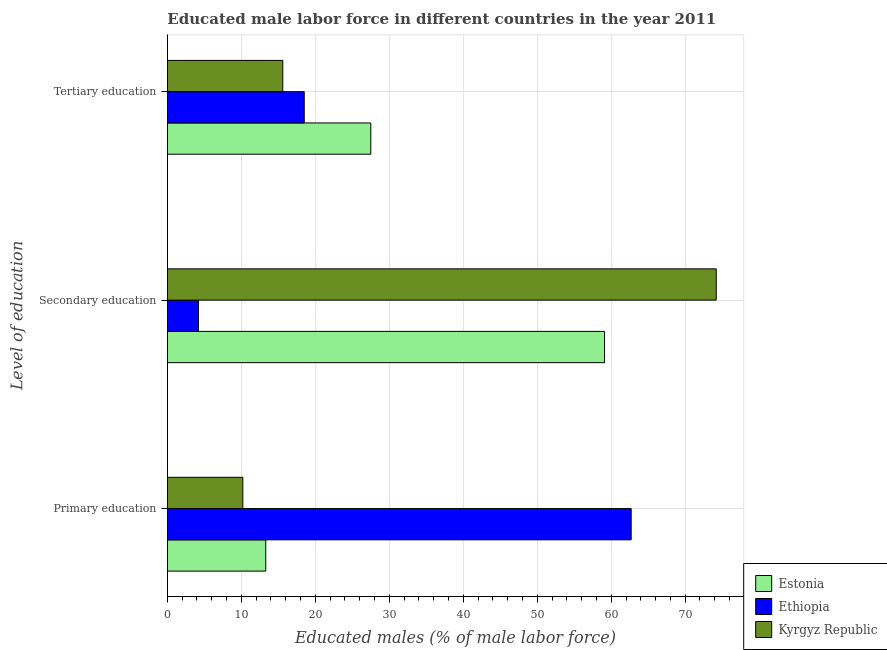Are the number of bars per tick equal to the number of legend labels?
Offer a terse response. Yes. Are the number of bars on each tick of the Y-axis equal?
Keep it short and to the point. Yes. What is the label of the 2nd group of bars from the top?
Ensure brevity in your answer.  Secondary education. What is the percentage of male labor force who received tertiary education in Estonia?
Your answer should be compact. 27.5. Across all countries, what is the maximum percentage of male labor force who received primary education?
Your answer should be compact. 62.7. Across all countries, what is the minimum percentage of male labor force who received secondary education?
Your answer should be compact. 4.2. In which country was the percentage of male labor force who received tertiary education maximum?
Provide a succinct answer. Estonia. In which country was the percentage of male labor force who received primary education minimum?
Keep it short and to the point. Kyrgyz Republic. What is the total percentage of male labor force who received primary education in the graph?
Offer a very short reply. 86.2. What is the difference between the percentage of male labor force who received primary education in Kyrgyz Republic and that in Estonia?
Provide a succinct answer. -3.1. What is the difference between the percentage of male labor force who received secondary education in Kyrgyz Republic and the percentage of male labor force who received tertiary education in Estonia?
Keep it short and to the point. 46.7. What is the average percentage of male labor force who received secondary education per country?
Your answer should be very brief. 45.83. What is the difference between the percentage of male labor force who received secondary education and percentage of male labor force who received primary education in Ethiopia?
Provide a succinct answer. -58.5. What is the ratio of the percentage of male labor force who received tertiary education in Ethiopia to that in Kyrgyz Republic?
Ensure brevity in your answer.  1.19. Is the difference between the percentage of male labor force who received tertiary education in Estonia and Kyrgyz Republic greater than the difference between the percentage of male labor force who received primary education in Estonia and Kyrgyz Republic?
Your response must be concise. Yes. What is the difference between the highest and the second highest percentage of male labor force who received tertiary education?
Give a very brief answer. 9. What is the difference between the highest and the lowest percentage of male labor force who received secondary education?
Provide a short and direct response. 70. In how many countries, is the percentage of male labor force who received tertiary education greater than the average percentage of male labor force who received tertiary education taken over all countries?
Provide a short and direct response. 1. What does the 2nd bar from the top in Primary education represents?
Offer a very short reply. Ethiopia. What does the 1st bar from the bottom in Primary education represents?
Provide a succinct answer. Estonia. Is it the case that in every country, the sum of the percentage of male labor force who received primary education and percentage of male labor force who received secondary education is greater than the percentage of male labor force who received tertiary education?
Make the answer very short. Yes. Are all the bars in the graph horizontal?
Give a very brief answer. Yes. How are the legend labels stacked?
Your answer should be very brief. Vertical. What is the title of the graph?
Give a very brief answer. Educated male labor force in different countries in the year 2011. Does "Angola" appear as one of the legend labels in the graph?
Offer a very short reply. No. What is the label or title of the X-axis?
Provide a short and direct response. Educated males (% of male labor force). What is the label or title of the Y-axis?
Offer a very short reply. Level of education. What is the Educated males (% of male labor force) in Estonia in Primary education?
Provide a succinct answer. 13.3. What is the Educated males (% of male labor force) in Ethiopia in Primary education?
Provide a succinct answer. 62.7. What is the Educated males (% of male labor force) of Kyrgyz Republic in Primary education?
Make the answer very short. 10.2. What is the Educated males (% of male labor force) in Estonia in Secondary education?
Your response must be concise. 59.1. What is the Educated males (% of male labor force) of Ethiopia in Secondary education?
Keep it short and to the point. 4.2. What is the Educated males (% of male labor force) in Kyrgyz Republic in Secondary education?
Keep it short and to the point. 74.2. What is the Educated males (% of male labor force) of Estonia in Tertiary education?
Provide a short and direct response. 27.5. What is the Educated males (% of male labor force) of Ethiopia in Tertiary education?
Your answer should be very brief. 18.5. What is the Educated males (% of male labor force) in Kyrgyz Republic in Tertiary education?
Your answer should be very brief. 15.6. Across all Level of education, what is the maximum Educated males (% of male labor force) in Estonia?
Your answer should be compact. 59.1. Across all Level of education, what is the maximum Educated males (% of male labor force) of Ethiopia?
Your answer should be very brief. 62.7. Across all Level of education, what is the maximum Educated males (% of male labor force) in Kyrgyz Republic?
Offer a terse response. 74.2. Across all Level of education, what is the minimum Educated males (% of male labor force) in Estonia?
Your answer should be compact. 13.3. Across all Level of education, what is the minimum Educated males (% of male labor force) of Ethiopia?
Make the answer very short. 4.2. Across all Level of education, what is the minimum Educated males (% of male labor force) in Kyrgyz Republic?
Provide a succinct answer. 10.2. What is the total Educated males (% of male labor force) of Estonia in the graph?
Give a very brief answer. 99.9. What is the total Educated males (% of male labor force) in Ethiopia in the graph?
Your answer should be very brief. 85.4. What is the total Educated males (% of male labor force) of Kyrgyz Republic in the graph?
Ensure brevity in your answer.  100. What is the difference between the Educated males (% of male labor force) in Estonia in Primary education and that in Secondary education?
Your answer should be very brief. -45.8. What is the difference between the Educated males (% of male labor force) in Ethiopia in Primary education and that in Secondary education?
Your answer should be compact. 58.5. What is the difference between the Educated males (% of male labor force) of Kyrgyz Republic in Primary education and that in Secondary education?
Provide a short and direct response. -64. What is the difference between the Educated males (% of male labor force) in Ethiopia in Primary education and that in Tertiary education?
Offer a very short reply. 44.2. What is the difference between the Educated males (% of male labor force) in Kyrgyz Republic in Primary education and that in Tertiary education?
Provide a succinct answer. -5.4. What is the difference between the Educated males (% of male labor force) of Estonia in Secondary education and that in Tertiary education?
Ensure brevity in your answer.  31.6. What is the difference between the Educated males (% of male labor force) in Ethiopia in Secondary education and that in Tertiary education?
Make the answer very short. -14.3. What is the difference between the Educated males (% of male labor force) of Kyrgyz Republic in Secondary education and that in Tertiary education?
Offer a very short reply. 58.6. What is the difference between the Educated males (% of male labor force) in Estonia in Primary education and the Educated males (% of male labor force) in Kyrgyz Republic in Secondary education?
Make the answer very short. -60.9. What is the difference between the Educated males (% of male labor force) of Ethiopia in Primary education and the Educated males (% of male labor force) of Kyrgyz Republic in Secondary education?
Your answer should be very brief. -11.5. What is the difference between the Educated males (% of male labor force) in Estonia in Primary education and the Educated males (% of male labor force) in Kyrgyz Republic in Tertiary education?
Provide a succinct answer. -2.3. What is the difference between the Educated males (% of male labor force) in Ethiopia in Primary education and the Educated males (% of male labor force) in Kyrgyz Republic in Tertiary education?
Give a very brief answer. 47.1. What is the difference between the Educated males (% of male labor force) of Estonia in Secondary education and the Educated males (% of male labor force) of Ethiopia in Tertiary education?
Your answer should be very brief. 40.6. What is the difference between the Educated males (% of male labor force) of Estonia in Secondary education and the Educated males (% of male labor force) of Kyrgyz Republic in Tertiary education?
Offer a very short reply. 43.5. What is the difference between the Educated males (% of male labor force) in Ethiopia in Secondary education and the Educated males (% of male labor force) in Kyrgyz Republic in Tertiary education?
Your answer should be compact. -11.4. What is the average Educated males (% of male labor force) of Estonia per Level of education?
Your response must be concise. 33.3. What is the average Educated males (% of male labor force) of Ethiopia per Level of education?
Make the answer very short. 28.47. What is the average Educated males (% of male labor force) of Kyrgyz Republic per Level of education?
Offer a very short reply. 33.33. What is the difference between the Educated males (% of male labor force) of Estonia and Educated males (% of male labor force) of Ethiopia in Primary education?
Make the answer very short. -49.4. What is the difference between the Educated males (% of male labor force) in Ethiopia and Educated males (% of male labor force) in Kyrgyz Republic in Primary education?
Your answer should be compact. 52.5. What is the difference between the Educated males (% of male labor force) in Estonia and Educated males (% of male labor force) in Ethiopia in Secondary education?
Provide a succinct answer. 54.9. What is the difference between the Educated males (% of male labor force) in Estonia and Educated males (% of male labor force) in Kyrgyz Republic in Secondary education?
Your response must be concise. -15.1. What is the difference between the Educated males (% of male labor force) in Ethiopia and Educated males (% of male labor force) in Kyrgyz Republic in Secondary education?
Offer a very short reply. -70. What is the difference between the Educated males (% of male labor force) of Estonia and Educated males (% of male labor force) of Ethiopia in Tertiary education?
Offer a terse response. 9. What is the ratio of the Educated males (% of male labor force) of Estonia in Primary education to that in Secondary education?
Your answer should be very brief. 0.23. What is the ratio of the Educated males (% of male labor force) in Ethiopia in Primary education to that in Secondary education?
Your answer should be compact. 14.93. What is the ratio of the Educated males (% of male labor force) in Kyrgyz Republic in Primary education to that in Secondary education?
Your answer should be very brief. 0.14. What is the ratio of the Educated males (% of male labor force) of Estonia in Primary education to that in Tertiary education?
Your answer should be compact. 0.48. What is the ratio of the Educated males (% of male labor force) in Ethiopia in Primary education to that in Tertiary education?
Offer a very short reply. 3.39. What is the ratio of the Educated males (% of male labor force) in Kyrgyz Republic in Primary education to that in Tertiary education?
Keep it short and to the point. 0.65. What is the ratio of the Educated males (% of male labor force) in Estonia in Secondary education to that in Tertiary education?
Give a very brief answer. 2.15. What is the ratio of the Educated males (% of male labor force) of Ethiopia in Secondary education to that in Tertiary education?
Offer a very short reply. 0.23. What is the ratio of the Educated males (% of male labor force) of Kyrgyz Republic in Secondary education to that in Tertiary education?
Make the answer very short. 4.76. What is the difference between the highest and the second highest Educated males (% of male labor force) in Estonia?
Your answer should be compact. 31.6. What is the difference between the highest and the second highest Educated males (% of male labor force) in Ethiopia?
Your answer should be very brief. 44.2. What is the difference between the highest and the second highest Educated males (% of male labor force) in Kyrgyz Republic?
Keep it short and to the point. 58.6. What is the difference between the highest and the lowest Educated males (% of male labor force) in Estonia?
Provide a succinct answer. 45.8. What is the difference between the highest and the lowest Educated males (% of male labor force) in Ethiopia?
Offer a very short reply. 58.5. 